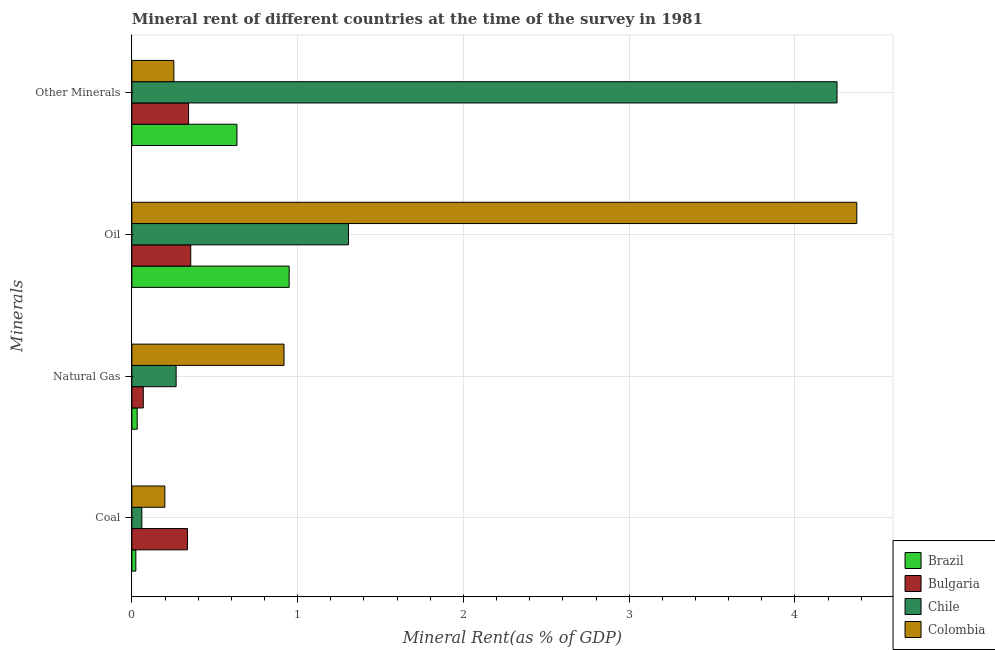How many different coloured bars are there?
Provide a short and direct response. 4. Are the number of bars per tick equal to the number of legend labels?
Provide a succinct answer. Yes. What is the label of the 4th group of bars from the top?
Provide a short and direct response. Coal. What is the coal rent in Chile?
Your answer should be compact. 0.06. Across all countries, what is the maximum natural gas rent?
Ensure brevity in your answer.  0.92. Across all countries, what is the minimum coal rent?
Give a very brief answer. 0.02. In which country was the natural gas rent maximum?
Offer a terse response. Colombia. What is the total oil rent in the graph?
Ensure brevity in your answer.  6.98. What is the difference between the oil rent in Colombia and that in Bulgaria?
Offer a terse response. 4.02. What is the difference between the natural gas rent in Bulgaria and the coal rent in Chile?
Keep it short and to the point. 0.01. What is the average  rent of other minerals per country?
Your answer should be very brief. 1.37. What is the difference between the oil rent and natural gas rent in Bulgaria?
Your answer should be very brief. 0.29. What is the ratio of the natural gas rent in Bulgaria to that in Colombia?
Offer a very short reply. 0.07. Is the difference between the natural gas rent in Bulgaria and Colombia greater than the difference between the coal rent in Bulgaria and Colombia?
Give a very brief answer. No. What is the difference between the highest and the second highest  rent of other minerals?
Your answer should be compact. 3.62. What is the difference between the highest and the lowest oil rent?
Keep it short and to the point. 4.02. In how many countries, is the natural gas rent greater than the average natural gas rent taken over all countries?
Provide a short and direct response. 1. Is the sum of the  rent of other minerals in Chile and Colombia greater than the maximum coal rent across all countries?
Your answer should be very brief. Yes. Is it the case that in every country, the sum of the oil rent and natural gas rent is greater than the sum of coal rent and  rent of other minerals?
Give a very brief answer. No. Is it the case that in every country, the sum of the coal rent and natural gas rent is greater than the oil rent?
Offer a terse response. No. How many bars are there?
Offer a very short reply. 16. Are the values on the major ticks of X-axis written in scientific E-notation?
Your answer should be very brief. No. Does the graph contain any zero values?
Make the answer very short. No. What is the title of the graph?
Your answer should be very brief. Mineral rent of different countries at the time of the survey in 1981. Does "Ukraine" appear as one of the legend labels in the graph?
Provide a succinct answer. No. What is the label or title of the X-axis?
Your answer should be compact. Mineral Rent(as % of GDP). What is the label or title of the Y-axis?
Provide a succinct answer. Minerals. What is the Mineral Rent(as % of GDP) of Brazil in Coal?
Your answer should be compact. 0.02. What is the Mineral Rent(as % of GDP) of Bulgaria in Coal?
Provide a short and direct response. 0.34. What is the Mineral Rent(as % of GDP) in Chile in Coal?
Offer a terse response. 0.06. What is the Mineral Rent(as % of GDP) of Colombia in Coal?
Provide a succinct answer. 0.2. What is the Mineral Rent(as % of GDP) of Brazil in Natural Gas?
Provide a short and direct response. 0.03. What is the Mineral Rent(as % of GDP) of Bulgaria in Natural Gas?
Make the answer very short. 0.07. What is the Mineral Rent(as % of GDP) in Chile in Natural Gas?
Your answer should be compact. 0.27. What is the Mineral Rent(as % of GDP) of Colombia in Natural Gas?
Offer a very short reply. 0.92. What is the Mineral Rent(as % of GDP) in Brazil in Oil?
Offer a very short reply. 0.95. What is the Mineral Rent(as % of GDP) of Bulgaria in Oil?
Provide a short and direct response. 0.36. What is the Mineral Rent(as % of GDP) in Chile in Oil?
Offer a terse response. 1.31. What is the Mineral Rent(as % of GDP) in Colombia in Oil?
Your answer should be very brief. 4.37. What is the Mineral Rent(as % of GDP) of Brazil in Other Minerals?
Your answer should be compact. 0.63. What is the Mineral Rent(as % of GDP) of Bulgaria in Other Minerals?
Provide a succinct answer. 0.34. What is the Mineral Rent(as % of GDP) of Chile in Other Minerals?
Your answer should be compact. 4.25. What is the Mineral Rent(as % of GDP) in Colombia in Other Minerals?
Provide a short and direct response. 0.25. Across all Minerals, what is the maximum Mineral Rent(as % of GDP) of Brazil?
Make the answer very short. 0.95. Across all Minerals, what is the maximum Mineral Rent(as % of GDP) of Bulgaria?
Provide a short and direct response. 0.36. Across all Minerals, what is the maximum Mineral Rent(as % of GDP) in Chile?
Provide a short and direct response. 4.25. Across all Minerals, what is the maximum Mineral Rent(as % of GDP) of Colombia?
Your answer should be compact. 4.37. Across all Minerals, what is the minimum Mineral Rent(as % of GDP) of Brazil?
Your response must be concise. 0.02. Across all Minerals, what is the minimum Mineral Rent(as % of GDP) of Bulgaria?
Ensure brevity in your answer.  0.07. Across all Minerals, what is the minimum Mineral Rent(as % of GDP) in Chile?
Offer a terse response. 0.06. Across all Minerals, what is the minimum Mineral Rent(as % of GDP) of Colombia?
Make the answer very short. 0.2. What is the total Mineral Rent(as % of GDP) of Brazil in the graph?
Provide a short and direct response. 1.64. What is the total Mineral Rent(as % of GDP) in Bulgaria in the graph?
Provide a short and direct response. 1.1. What is the total Mineral Rent(as % of GDP) in Chile in the graph?
Ensure brevity in your answer.  5.89. What is the total Mineral Rent(as % of GDP) of Colombia in the graph?
Your response must be concise. 5.74. What is the difference between the Mineral Rent(as % of GDP) of Brazil in Coal and that in Natural Gas?
Offer a terse response. -0.01. What is the difference between the Mineral Rent(as % of GDP) of Bulgaria in Coal and that in Natural Gas?
Ensure brevity in your answer.  0.27. What is the difference between the Mineral Rent(as % of GDP) of Chile in Coal and that in Natural Gas?
Ensure brevity in your answer.  -0.21. What is the difference between the Mineral Rent(as % of GDP) of Colombia in Coal and that in Natural Gas?
Ensure brevity in your answer.  -0.72. What is the difference between the Mineral Rent(as % of GDP) of Brazil in Coal and that in Oil?
Your answer should be compact. -0.92. What is the difference between the Mineral Rent(as % of GDP) of Bulgaria in Coal and that in Oil?
Ensure brevity in your answer.  -0.02. What is the difference between the Mineral Rent(as % of GDP) of Chile in Coal and that in Oil?
Your answer should be compact. -1.25. What is the difference between the Mineral Rent(as % of GDP) in Colombia in Coal and that in Oil?
Your response must be concise. -4.17. What is the difference between the Mineral Rent(as % of GDP) in Brazil in Coal and that in Other Minerals?
Provide a short and direct response. -0.61. What is the difference between the Mineral Rent(as % of GDP) in Bulgaria in Coal and that in Other Minerals?
Give a very brief answer. -0.01. What is the difference between the Mineral Rent(as % of GDP) in Chile in Coal and that in Other Minerals?
Make the answer very short. -4.19. What is the difference between the Mineral Rent(as % of GDP) of Colombia in Coal and that in Other Minerals?
Offer a terse response. -0.05. What is the difference between the Mineral Rent(as % of GDP) of Brazil in Natural Gas and that in Oil?
Ensure brevity in your answer.  -0.92. What is the difference between the Mineral Rent(as % of GDP) in Bulgaria in Natural Gas and that in Oil?
Offer a terse response. -0.29. What is the difference between the Mineral Rent(as % of GDP) of Chile in Natural Gas and that in Oil?
Your answer should be very brief. -1.04. What is the difference between the Mineral Rent(as % of GDP) in Colombia in Natural Gas and that in Oil?
Make the answer very short. -3.46. What is the difference between the Mineral Rent(as % of GDP) of Brazil in Natural Gas and that in Other Minerals?
Offer a very short reply. -0.6. What is the difference between the Mineral Rent(as % of GDP) of Bulgaria in Natural Gas and that in Other Minerals?
Make the answer very short. -0.27. What is the difference between the Mineral Rent(as % of GDP) in Chile in Natural Gas and that in Other Minerals?
Ensure brevity in your answer.  -3.99. What is the difference between the Mineral Rent(as % of GDP) of Colombia in Natural Gas and that in Other Minerals?
Make the answer very short. 0.66. What is the difference between the Mineral Rent(as % of GDP) of Brazil in Oil and that in Other Minerals?
Your response must be concise. 0.31. What is the difference between the Mineral Rent(as % of GDP) of Bulgaria in Oil and that in Other Minerals?
Your answer should be compact. 0.01. What is the difference between the Mineral Rent(as % of GDP) of Chile in Oil and that in Other Minerals?
Provide a short and direct response. -2.95. What is the difference between the Mineral Rent(as % of GDP) of Colombia in Oil and that in Other Minerals?
Your response must be concise. 4.12. What is the difference between the Mineral Rent(as % of GDP) in Brazil in Coal and the Mineral Rent(as % of GDP) in Bulgaria in Natural Gas?
Give a very brief answer. -0.04. What is the difference between the Mineral Rent(as % of GDP) of Brazil in Coal and the Mineral Rent(as % of GDP) of Chile in Natural Gas?
Your answer should be very brief. -0.24. What is the difference between the Mineral Rent(as % of GDP) in Brazil in Coal and the Mineral Rent(as % of GDP) in Colombia in Natural Gas?
Your answer should be compact. -0.89. What is the difference between the Mineral Rent(as % of GDP) of Bulgaria in Coal and the Mineral Rent(as % of GDP) of Chile in Natural Gas?
Provide a short and direct response. 0.07. What is the difference between the Mineral Rent(as % of GDP) of Bulgaria in Coal and the Mineral Rent(as % of GDP) of Colombia in Natural Gas?
Provide a succinct answer. -0.58. What is the difference between the Mineral Rent(as % of GDP) of Chile in Coal and the Mineral Rent(as % of GDP) of Colombia in Natural Gas?
Offer a terse response. -0.86. What is the difference between the Mineral Rent(as % of GDP) in Brazil in Coal and the Mineral Rent(as % of GDP) in Bulgaria in Oil?
Give a very brief answer. -0.33. What is the difference between the Mineral Rent(as % of GDP) of Brazil in Coal and the Mineral Rent(as % of GDP) of Chile in Oil?
Offer a very short reply. -1.28. What is the difference between the Mineral Rent(as % of GDP) of Brazil in Coal and the Mineral Rent(as % of GDP) of Colombia in Oil?
Your response must be concise. -4.35. What is the difference between the Mineral Rent(as % of GDP) in Bulgaria in Coal and the Mineral Rent(as % of GDP) in Chile in Oil?
Your answer should be very brief. -0.97. What is the difference between the Mineral Rent(as % of GDP) in Bulgaria in Coal and the Mineral Rent(as % of GDP) in Colombia in Oil?
Provide a short and direct response. -4.04. What is the difference between the Mineral Rent(as % of GDP) of Chile in Coal and the Mineral Rent(as % of GDP) of Colombia in Oil?
Keep it short and to the point. -4.31. What is the difference between the Mineral Rent(as % of GDP) in Brazil in Coal and the Mineral Rent(as % of GDP) in Bulgaria in Other Minerals?
Make the answer very short. -0.32. What is the difference between the Mineral Rent(as % of GDP) of Brazil in Coal and the Mineral Rent(as % of GDP) of Chile in Other Minerals?
Make the answer very short. -4.23. What is the difference between the Mineral Rent(as % of GDP) of Brazil in Coal and the Mineral Rent(as % of GDP) of Colombia in Other Minerals?
Keep it short and to the point. -0.23. What is the difference between the Mineral Rent(as % of GDP) of Bulgaria in Coal and the Mineral Rent(as % of GDP) of Chile in Other Minerals?
Ensure brevity in your answer.  -3.92. What is the difference between the Mineral Rent(as % of GDP) of Bulgaria in Coal and the Mineral Rent(as % of GDP) of Colombia in Other Minerals?
Provide a succinct answer. 0.08. What is the difference between the Mineral Rent(as % of GDP) of Chile in Coal and the Mineral Rent(as % of GDP) of Colombia in Other Minerals?
Make the answer very short. -0.19. What is the difference between the Mineral Rent(as % of GDP) in Brazil in Natural Gas and the Mineral Rent(as % of GDP) in Bulgaria in Oil?
Provide a short and direct response. -0.32. What is the difference between the Mineral Rent(as % of GDP) in Brazil in Natural Gas and the Mineral Rent(as % of GDP) in Chile in Oil?
Ensure brevity in your answer.  -1.27. What is the difference between the Mineral Rent(as % of GDP) in Brazil in Natural Gas and the Mineral Rent(as % of GDP) in Colombia in Oil?
Offer a terse response. -4.34. What is the difference between the Mineral Rent(as % of GDP) of Bulgaria in Natural Gas and the Mineral Rent(as % of GDP) of Chile in Oil?
Ensure brevity in your answer.  -1.24. What is the difference between the Mineral Rent(as % of GDP) of Bulgaria in Natural Gas and the Mineral Rent(as % of GDP) of Colombia in Oil?
Offer a very short reply. -4.3. What is the difference between the Mineral Rent(as % of GDP) of Chile in Natural Gas and the Mineral Rent(as % of GDP) of Colombia in Oil?
Your answer should be compact. -4.11. What is the difference between the Mineral Rent(as % of GDP) of Brazil in Natural Gas and the Mineral Rent(as % of GDP) of Bulgaria in Other Minerals?
Provide a succinct answer. -0.31. What is the difference between the Mineral Rent(as % of GDP) of Brazil in Natural Gas and the Mineral Rent(as % of GDP) of Chile in Other Minerals?
Provide a short and direct response. -4.22. What is the difference between the Mineral Rent(as % of GDP) in Brazil in Natural Gas and the Mineral Rent(as % of GDP) in Colombia in Other Minerals?
Ensure brevity in your answer.  -0.22. What is the difference between the Mineral Rent(as % of GDP) in Bulgaria in Natural Gas and the Mineral Rent(as % of GDP) in Chile in Other Minerals?
Offer a very short reply. -4.18. What is the difference between the Mineral Rent(as % of GDP) in Bulgaria in Natural Gas and the Mineral Rent(as % of GDP) in Colombia in Other Minerals?
Offer a very short reply. -0.18. What is the difference between the Mineral Rent(as % of GDP) of Chile in Natural Gas and the Mineral Rent(as % of GDP) of Colombia in Other Minerals?
Provide a short and direct response. 0.01. What is the difference between the Mineral Rent(as % of GDP) in Brazil in Oil and the Mineral Rent(as % of GDP) in Bulgaria in Other Minerals?
Offer a terse response. 0.61. What is the difference between the Mineral Rent(as % of GDP) of Brazil in Oil and the Mineral Rent(as % of GDP) of Chile in Other Minerals?
Your answer should be compact. -3.31. What is the difference between the Mineral Rent(as % of GDP) of Brazil in Oil and the Mineral Rent(as % of GDP) of Colombia in Other Minerals?
Your answer should be very brief. 0.7. What is the difference between the Mineral Rent(as % of GDP) of Bulgaria in Oil and the Mineral Rent(as % of GDP) of Chile in Other Minerals?
Provide a short and direct response. -3.9. What is the difference between the Mineral Rent(as % of GDP) of Bulgaria in Oil and the Mineral Rent(as % of GDP) of Colombia in Other Minerals?
Keep it short and to the point. 0.1. What is the difference between the Mineral Rent(as % of GDP) in Chile in Oil and the Mineral Rent(as % of GDP) in Colombia in Other Minerals?
Offer a very short reply. 1.05. What is the average Mineral Rent(as % of GDP) of Brazil per Minerals?
Offer a very short reply. 0.41. What is the average Mineral Rent(as % of GDP) of Bulgaria per Minerals?
Offer a terse response. 0.28. What is the average Mineral Rent(as % of GDP) in Chile per Minerals?
Give a very brief answer. 1.47. What is the average Mineral Rent(as % of GDP) of Colombia per Minerals?
Offer a terse response. 1.44. What is the difference between the Mineral Rent(as % of GDP) of Brazil and Mineral Rent(as % of GDP) of Bulgaria in Coal?
Your answer should be compact. -0.31. What is the difference between the Mineral Rent(as % of GDP) in Brazil and Mineral Rent(as % of GDP) in Chile in Coal?
Provide a succinct answer. -0.04. What is the difference between the Mineral Rent(as % of GDP) in Brazil and Mineral Rent(as % of GDP) in Colombia in Coal?
Make the answer very short. -0.17. What is the difference between the Mineral Rent(as % of GDP) of Bulgaria and Mineral Rent(as % of GDP) of Chile in Coal?
Keep it short and to the point. 0.28. What is the difference between the Mineral Rent(as % of GDP) in Bulgaria and Mineral Rent(as % of GDP) in Colombia in Coal?
Make the answer very short. 0.14. What is the difference between the Mineral Rent(as % of GDP) of Chile and Mineral Rent(as % of GDP) of Colombia in Coal?
Your answer should be very brief. -0.14. What is the difference between the Mineral Rent(as % of GDP) of Brazil and Mineral Rent(as % of GDP) of Bulgaria in Natural Gas?
Your answer should be very brief. -0.04. What is the difference between the Mineral Rent(as % of GDP) of Brazil and Mineral Rent(as % of GDP) of Chile in Natural Gas?
Your answer should be very brief. -0.23. What is the difference between the Mineral Rent(as % of GDP) in Brazil and Mineral Rent(as % of GDP) in Colombia in Natural Gas?
Offer a very short reply. -0.89. What is the difference between the Mineral Rent(as % of GDP) in Bulgaria and Mineral Rent(as % of GDP) in Chile in Natural Gas?
Ensure brevity in your answer.  -0.2. What is the difference between the Mineral Rent(as % of GDP) in Bulgaria and Mineral Rent(as % of GDP) in Colombia in Natural Gas?
Your answer should be very brief. -0.85. What is the difference between the Mineral Rent(as % of GDP) of Chile and Mineral Rent(as % of GDP) of Colombia in Natural Gas?
Your answer should be compact. -0.65. What is the difference between the Mineral Rent(as % of GDP) of Brazil and Mineral Rent(as % of GDP) of Bulgaria in Oil?
Offer a very short reply. 0.59. What is the difference between the Mineral Rent(as % of GDP) in Brazil and Mineral Rent(as % of GDP) in Chile in Oil?
Provide a short and direct response. -0.36. What is the difference between the Mineral Rent(as % of GDP) of Brazil and Mineral Rent(as % of GDP) of Colombia in Oil?
Give a very brief answer. -3.42. What is the difference between the Mineral Rent(as % of GDP) in Bulgaria and Mineral Rent(as % of GDP) in Chile in Oil?
Keep it short and to the point. -0.95. What is the difference between the Mineral Rent(as % of GDP) of Bulgaria and Mineral Rent(as % of GDP) of Colombia in Oil?
Your response must be concise. -4.02. What is the difference between the Mineral Rent(as % of GDP) of Chile and Mineral Rent(as % of GDP) of Colombia in Oil?
Ensure brevity in your answer.  -3.07. What is the difference between the Mineral Rent(as % of GDP) in Brazil and Mineral Rent(as % of GDP) in Bulgaria in Other Minerals?
Your answer should be compact. 0.29. What is the difference between the Mineral Rent(as % of GDP) in Brazil and Mineral Rent(as % of GDP) in Chile in Other Minerals?
Offer a very short reply. -3.62. What is the difference between the Mineral Rent(as % of GDP) of Brazil and Mineral Rent(as % of GDP) of Colombia in Other Minerals?
Keep it short and to the point. 0.38. What is the difference between the Mineral Rent(as % of GDP) in Bulgaria and Mineral Rent(as % of GDP) in Chile in Other Minerals?
Ensure brevity in your answer.  -3.91. What is the difference between the Mineral Rent(as % of GDP) in Bulgaria and Mineral Rent(as % of GDP) in Colombia in Other Minerals?
Your answer should be very brief. 0.09. What is the difference between the Mineral Rent(as % of GDP) of Chile and Mineral Rent(as % of GDP) of Colombia in Other Minerals?
Your answer should be compact. 4. What is the ratio of the Mineral Rent(as % of GDP) in Brazil in Coal to that in Natural Gas?
Give a very brief answer. 0.75. What is the ratio of the Mineral Rent(as % of GDP) in Bulgaria in Coal to that in Natural Gas?
Provide a short and direct response. 4.87. What is the ratio of the Mineral Rent(as % of GDP) of Chile in Coal to that in Natural Gas?
Offer a terse response. 0.23. What is the ratio of the Mineral Rent(as % of GDP) in Colombia in Coal to that in Natural Gas?
Your response must be concise. 0.22. What is the ratio of the Mineral Rent(as % of GDP) of Brazil in Coal to that in Oil?
Offer a terse response. 0.03. What is the ratio of the Mineral Rent(as % of GDP) in Bulgaria in Coal to that in Oil?
Provide a succinct answer. 0.94. What is the ratio of the Mineral Rent(as % of GDP) in Chile in Coal to that in Oil?
Ensure brevity in your answer.  0.05. What is the ratio of the Mineral Rent(as % of GDP) in Colombia in Coal to that in Oil?
Provide a short and direct response. 0.05. What is the ratio of the Mineral Rent(as % of GDP) of Brazil in Coal to that in Other Minerals?
Provide a succinct answer. 0.04. What is the ratio of the Mineral Rent(as % of GDP) in Bulgaria in Coal to that in Other Minerals?
Make the answer very short. 0.98. What is the ratio of the Mineral Rent(as % of GDP) of Chile in Coal to that in Other Minerals?
Give a very brief answer. 0.01. What is the ratio of the Mineral Rent(as % of GDP) of Colombia in Coal to that in Other Minerals?
Your answer should be very brief. 0.79. What is the ratio of the Mineral Rent(as % of GDP) in Brazil in Natural Gas to that in Oil?
Your response must be concise. 0.03. What is the ratio of the Mineral Rent(as % of GDP) in Bulgaria in Natural Gas to that in Oil?
Offer a very short reply. 0.19. What is the ratio of the Mineral Rent(as % of GDP) in Chile in Natural Gas to that in Oil?
Offer a very short reply. 0.2. What is the ratio of the Mineral Rent(as % of GDP) of Colombia in Natural Gas to that in Oil?
Provide a succinct answer. 0.21. What is the ratio of the Mineral Rent(as % of GDP) in Brazil in Natural Gas to that in Other Minerals?
Make the answer very short. 0.05. What is the ratio of the Mineral Rent(as % of GDP) in Bulgaria in Natural Gas to that in Other Minerals?
Your answer should be compact. 0.2. What is the ratio of the Mineral Rent(as % of GDP) in Chile in Natural Gas to that in Other Minerals?
Give a very brief answer. 0.06. What is the ratio of the Mineral Rent(as % of GDP) of Colombia in Natural Gas to that in Other Minerals?
Your response must be concise. 3.62. What is the ratio of the Mineral Rent(as % of GDP) in Brazil in Oil to that in Other Minerals?
Your response must be concise. 1.5. What is the ratio of the Mineral Rent(as % of GDP) of Bulgaria in Oil to that in Other Minerals?
Make the answer very short. 1.04. What is the ratio of the Mineral Rent(as % of GDP) in Chile in Oil to that in Other Minerals?
Provide a short and direct response. 0.31. What is the ratio of the Mineral Rent(as % of GDP) of Colombia in Oil to that in Other Minerals?
Provide a short and direct response. 17.27. What is the difference between the highest and the second highest Mineral Rent(as % of GDP) of Brazil?
Offer a very short reply. 0.31. What is the difference between the highest and the second highest Mineral Rent(as % of GDP) in Bulgaria?
Your answer should be very brief. 0.01. What is the difference between the highest and the second highest Mineral Rent(as % of GDP) in Chile?
Your answer should be very brief. 2.95. What is the difference between the highest and the second highest Mineral Rent(as % of GDP) in Colombia?
Provide a short and direct response. 3.46. What is the difference between the highest and the lowest Mineral Rent(as % of GDP) of Brazil?
Your response must be concise. 0.92. What is the difference between the highest and the lowest Mineral Rent(as % of GDP) in Bulgaria?
Your answer should be compact. 0.29. What is the difference between the highest and the lowest Mineral Rent(as % of GDP) of Chile?
Provide a succinct answer. 4.19. What is the difference between the highest and the lowest Mineral Rent(as % of GDP) in Colombia?
Your answer should be compact. 4.17. 